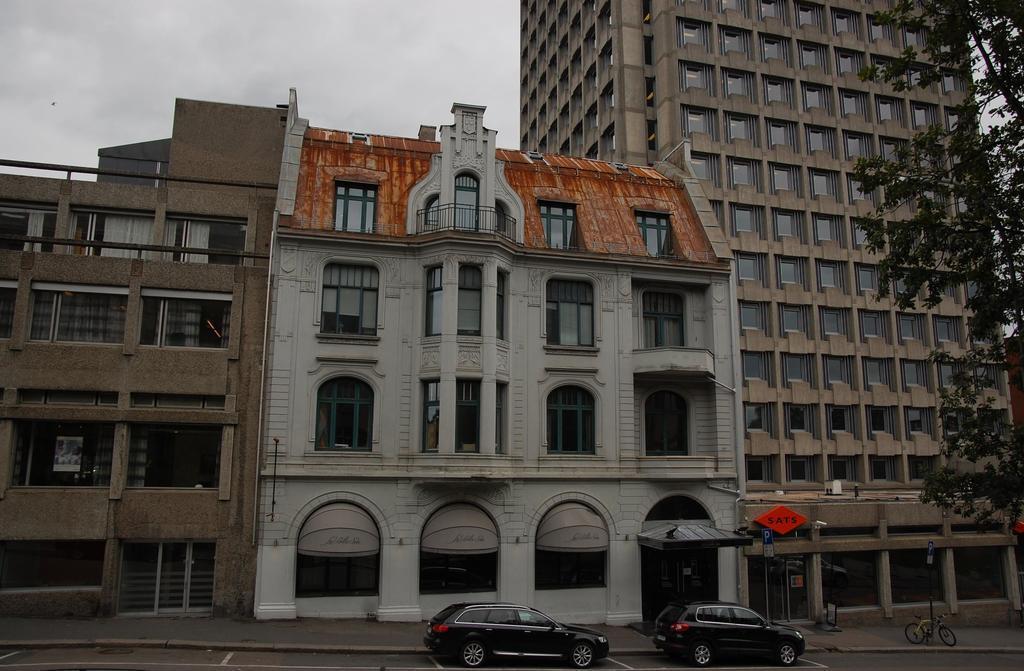Describe this image in one or two sentences. In this image, we can see buildings, trees and poles. At the bottom, there are vehicles on the road. At the top, there is sky. 